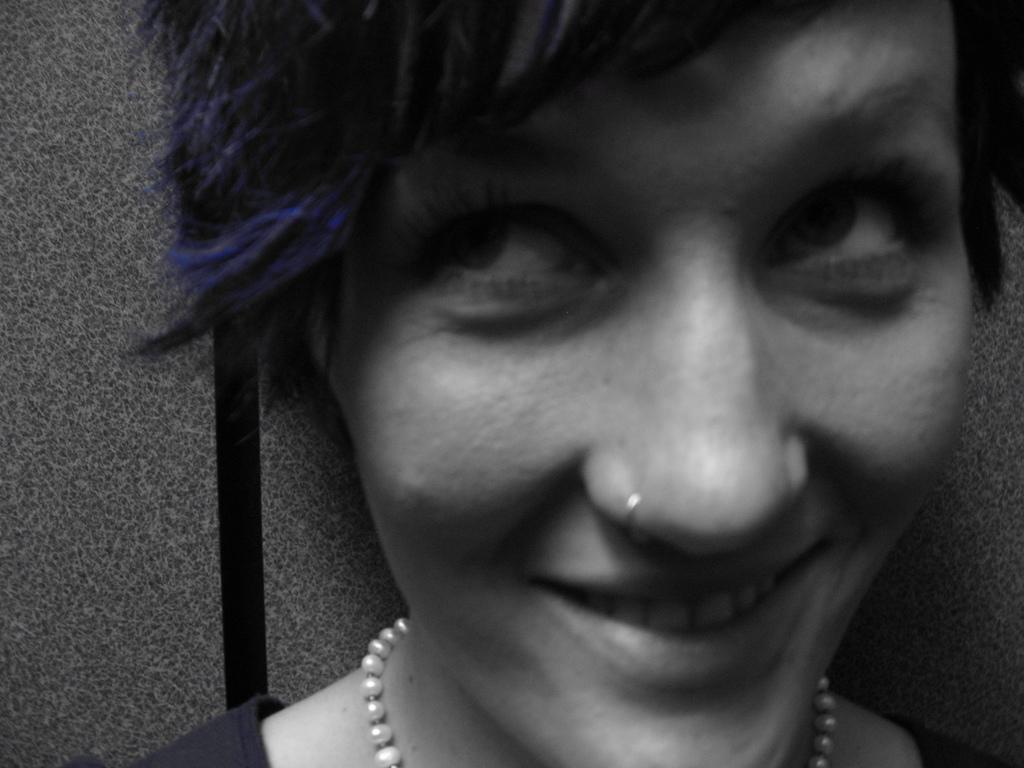How would you summarize this image in a sentence or two? This is a zoomed in picture. In the foreground there is a person wearing pearl necklace, nose ring, and smiling. In the background there is an object seems to be the wall. 